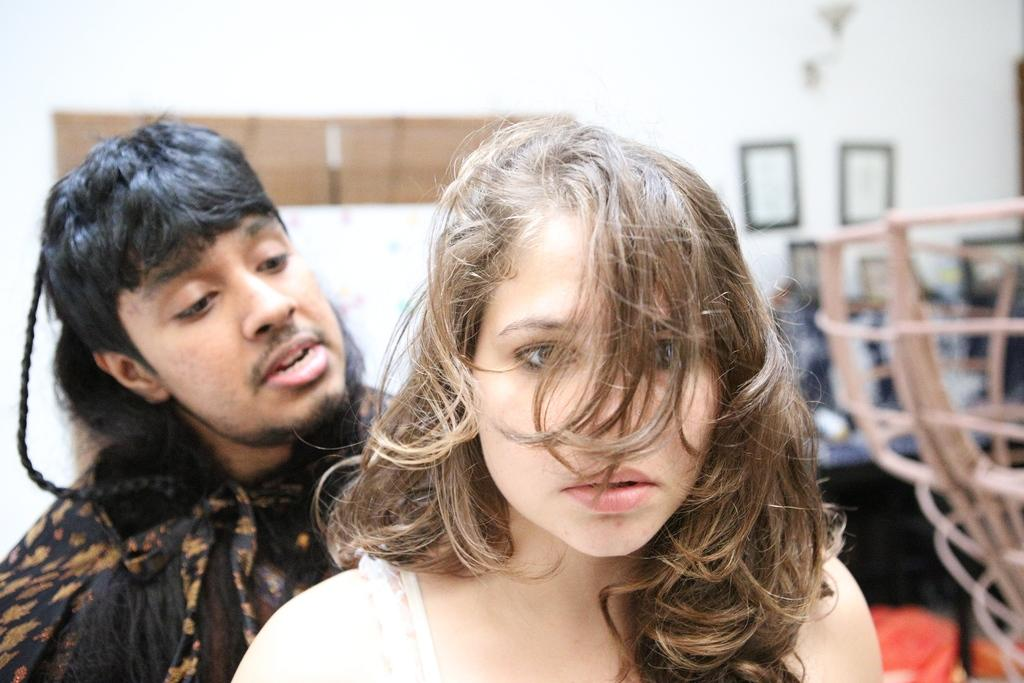How many people are present in the image? There are two people standing in the image. What can be seen in the background of the image? There are objects in the background of the image. Can you describe the quality of the image? The image is blurred. Where is the hole in the image? There is no hole present in the image. Can you describe the kiss between the two people in the image? There is no kiss between the two people in the image; they are simply standing. 